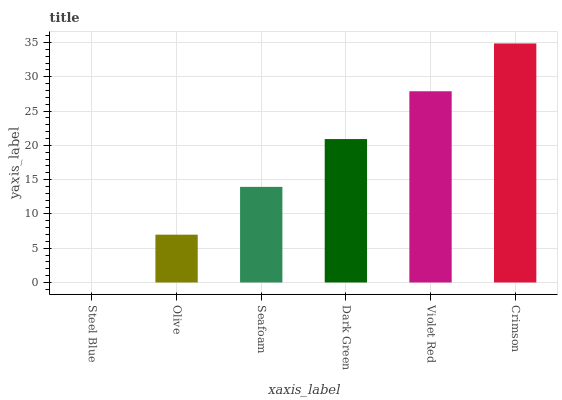Is Steel Blue the minimum?
Answer yes or no. Yes. Is Crimson the maximum?
Answer yes or no. Yes. Is Olive the minimum?
Answer yes or no. No. Is Olive the maximum?
Answer yes or no. No. Is Olive greater than Steel Blue?
Answer yes or no. Yes. Is Steel Blue less than Olive?
Answer yes or no. Yes. Is Steel Blue greater than Olive?
Answer yes or no. No. Is Olive less than Steel Blue?
Answer yes or no. No. Is Dark Green the high median?
Answer yes or no. Yes. Is Seafoam the low median?
Answer yes or no. Yes. Is Seafoam the high median?
Answer yes or no. No. Is Dark Green the low median?
Answer yes or no. No. 